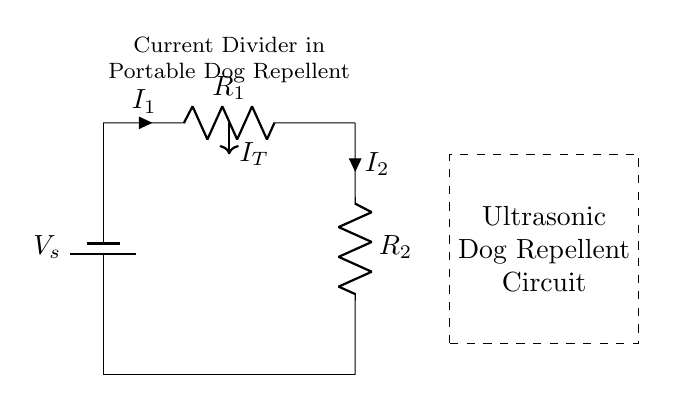What is the source voltage in this circuit? The source voltage is labeled as V sub s at the top of the circuit diagram and is typically the input voltage for the circuit.
Answer: V sub s What are the two resistors in this circuit? The resistors are labeled R sub 1 and R sub 2 in the diagram, which indicates the presence of two distinct resistance components.
Answer: R sub 1 and R sub 2 What is the total current entering the circuit? The total current entering the circuit is represented by I sub T, which flows into the junction of the resistors R sub 1 and R sub 2.
Answer: I sub T How is the current divided between the resistors? The current divides according to the resistance values of R sub 1 and R sub 2. The relationship is defined by the current divider rule, where current through each resistor is inversely proportional to its resistance.
Answer: According to resistance values What is the function of the circuit diagram? The function is to repel dogs using ultrasonic signals, as indicated by the label provided in the circuit diagram.
Answer: Ultrasonic dog repellent What happens if R sub 1 is much larger than R sub 2? If R sub 1 is much larger than R sub 2, most of the total current I sub T will flow through R sub 2, causing I sub 1 to be significantly smaller than I sub 2, demonstrating the principles of the current divider rule effectively.
Answer: Most current through R sub 2 